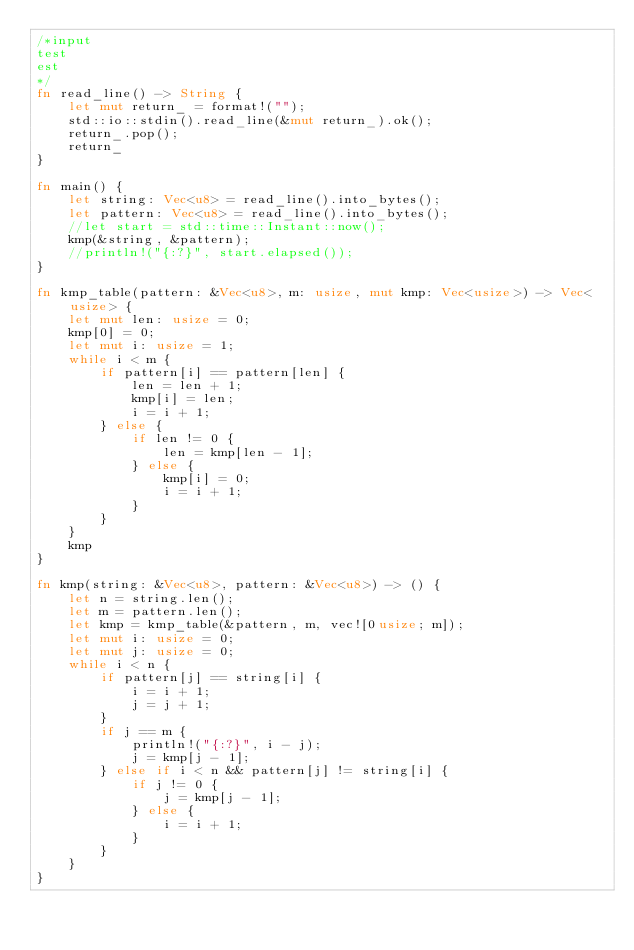<code> <loc_0><loc_0><loc_500><loc_500><_Rust_>/*input
test
est
*/
fn read_line() -> String {
    let mut return_ = format!("");
    std::io::stdin().read_line(&mut return_).ok();
    return_.pop();
    return_
}

fn main() {
    let string: Vec<u8> = read_line().into_bytes();
    let pattern: Vec<u8> = read_line().into_bytes();
    //let start = std::time::Instant::now();
    kmp(&string, &pattern);
    //println!("{:?}", start.elapsed());
}

fn kmp_table(pattern: &Vec<u8>, m: usize, mut kmp: Vec<usize>) -> Vec<usize> {
    let mut len: usize = 0;
    kmp[0] = 0;
    let mut i: usize = 1;
    while i < m {
        if pattern[i] == pattern[len] {
            len = len + 1;
            kmp[i] = len;
            i = i + 1;
        } else {
            if len != 0 {
                len = kmp[len - 1];
            } else {
                kmp[i] = 0;
                i = i + 1;
            }
        }
    }
    kmp
}

fn kmp(string: &Vec<u8>, pattern: &Vec<u8>) -> () {
    let n = string.len();
    let m = pattern.len();
    let kmp = kmp_table(&pattern, m, vec![0usize; m]);
    let mut i: usize = 0;
    let mut j: usize = 0;
    while i < n {
        if pattern[j] == string[i] {
            i = i + 1;
            j = j + 1;
        }
        if j == m {
            println!("{:?}", i - j);
            j = kmp[j - 1];
        } else if i < n && pattern[j] != string[i] {
            if j != 0 {
                j = kmp[j - 1];
            } else {
                i = i + 1;
            }
        }
    }
}

</code> 